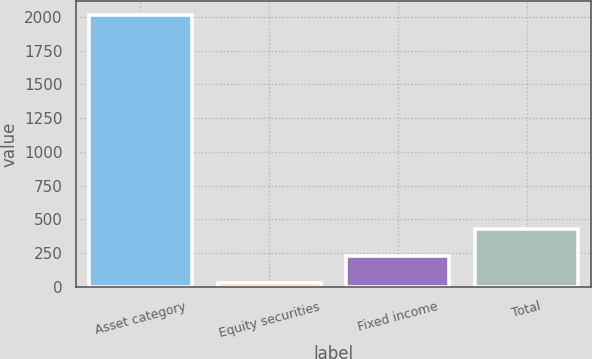<chart> <loc_0><loc_0><loc_500><loc_500><bar_chart><fcel>Asset category<fcel>Equity securities<fcel>Fixed income<fcel>Total<nl><fcel>2014<fcel>30<fcel>228.4<fcel>426.8<nl></chart> 